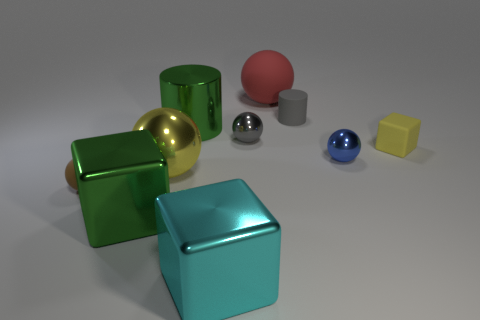What can you infer about the texture of the surfaces in this image? The surfaces of the objects appear smooth and highly polished. The clear reflections and the way the light bounces off each item suggest that the textures are sleek and possibly metallic or plastic in nature. 